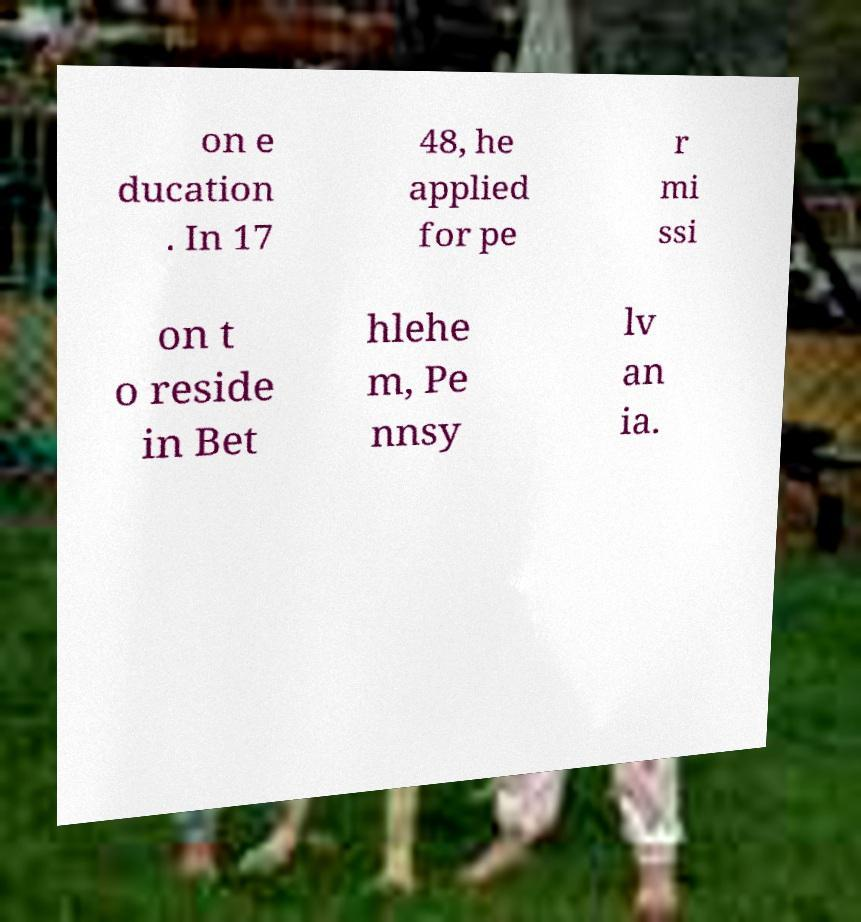Could you assist in decoding the text presented in this image and type it out clearly? on e ducation . In 17 48, he applied for pe r mi ssi on t o reside in Bet hlehe m, Pe nnsy lv an ia. 